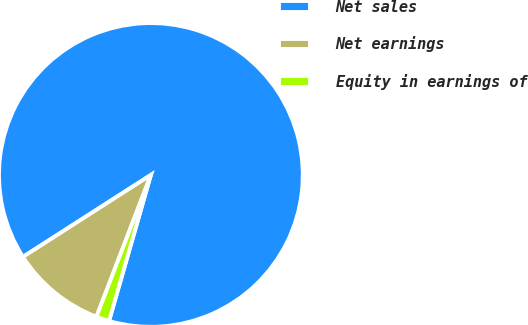Convert chart to OTSL. <chart><loc_0><loc_0><loc_500><loc_500><pie_chart><fcel>Net sales<fcel>Net earnings<fcel>Equity in earnings of<nl><fcel>88.51%<fcel>10.1%<fcel>1.39%<nl></chart> 